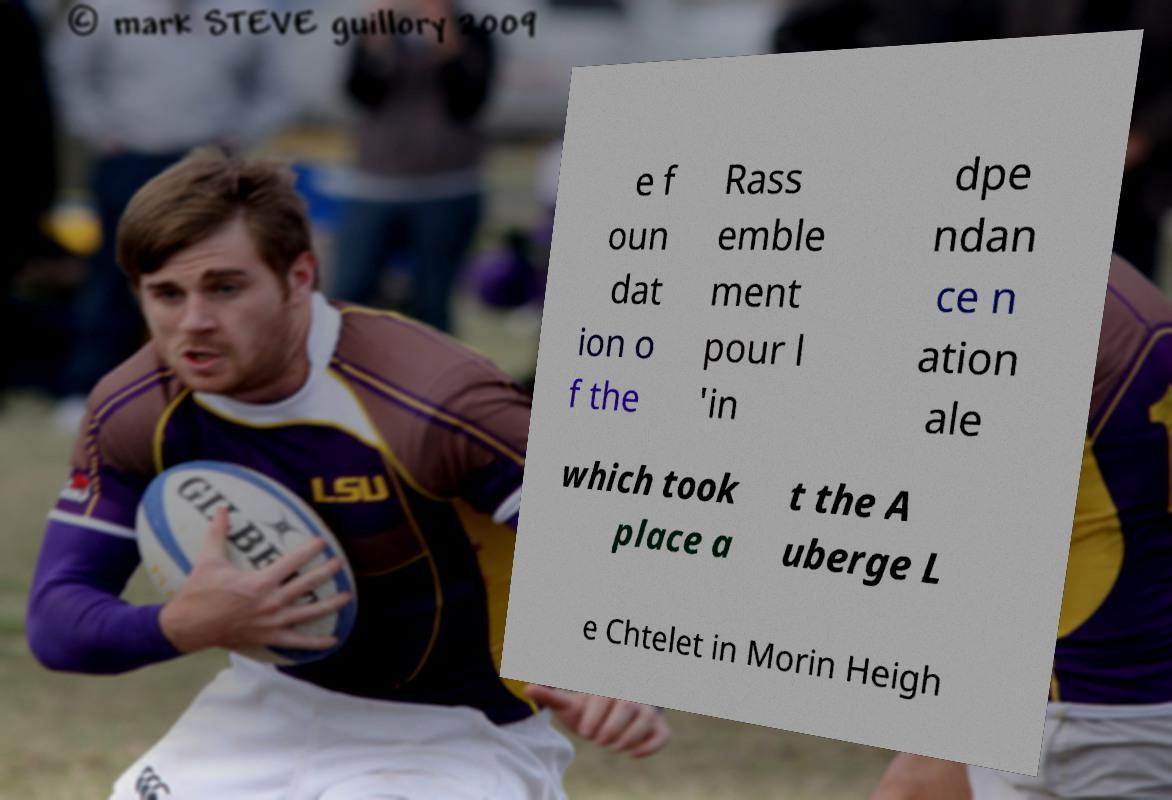Please identify and transcribe the text found in this image. e f oun dat ion o f the Rass emble ment pour l 'in dpe ndan ce n ation ale which took place a t the A uberge L e Chtelet in Morin Heigh 